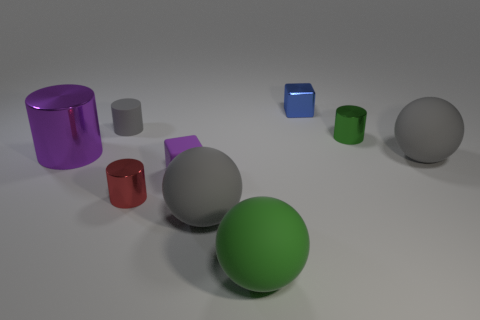What is the shape of the small thing that is the same color as the big shiny cylinder?
Make the answer very short. Cube. How many other things are made of the same material as the tiny purple thing?
Offer a terse response. 4. The purple thing that is the same shape as the green shiny thing is what size?
Offer a very short reply. Large. What is the material of the small cube that is in front of the matte object that is behind the big purple cylinder?
Your response must be concise. Rubber. Do the tiny red metal thing and the big metal thing have the same shape?
Your response must be concise. Yes. What number of small cylinders are both on the left side of the green rubber thing and on the right side of the blue shiny object?
Give a very brief answer. 0. Is the number of large rubber balls that are on the left side of the big purple cylinder the same as the number of blocks behind the purple rubber object?
Ensure brevity in your answer.  No. There is a gray ball that is right of the metal cube; does it have the same size as the metal thing that is right of the blue block?
Offer a terse response. No. What material is the thing that is both behind the green metal cylinder and in front of the shiny block?
Offer a terse response. Rubber. Is the number of large cylinders less than the number of large red objects?
Provide a short and direct response. No. 